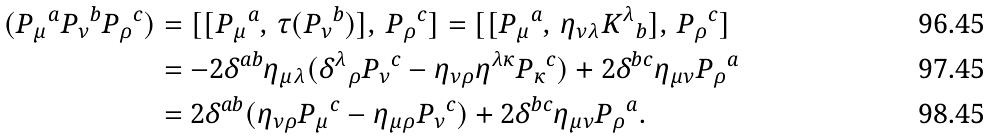Convert formula to latex. <formula><loc_0><loc_0><loc_500><loc_500>( { P _ { \mu } } ^ { a } { P _ { \nu } } ^ { b } { P _ { \rho } } ^ { c } ) & = [ [ { P _ { \mu } } ^ { a } , \, \tau ( { P _ { \nu } } ^ { b } ) ] , \, { P _ { \rho } } ^ { c } ] = [ [ { P _ { \mu } } ^ { a } , \, { \eta } _ { \nu \lambda } { K ^ { \lambda } } _ { b } ] , \, { P _ { \rho } } ^ { c } ] \\ & = - 2 { \delta } ^ { a b } { \eta } _ { \mu \lambda } ( { { \delta } ^ { \lambda } } _ { \rho } { P _ { \nu } } ^ { c } - { \eta } _ { \nu \rho } { \eta } ^ { \lambda \kappa } { P _ { \kappa } } ^ { c } ) + 2 { \delta } ^ { b c } { \eta } _ { \mu \nu } { P _ { \rho } } ^ { a } \\ & = 2 { \delta } ^ { a b } ( { \eta } _ { \nu \rho } { P _ { \mu } } ^ { c } - { \eta } _ { \mu \rho } { P _ { \nu } } ^ { c } ) + 2 { \delta } ^ { b c } { \eta } _ { \mu \nu } { P _ { \rho } } ^ { a } .</formula> 